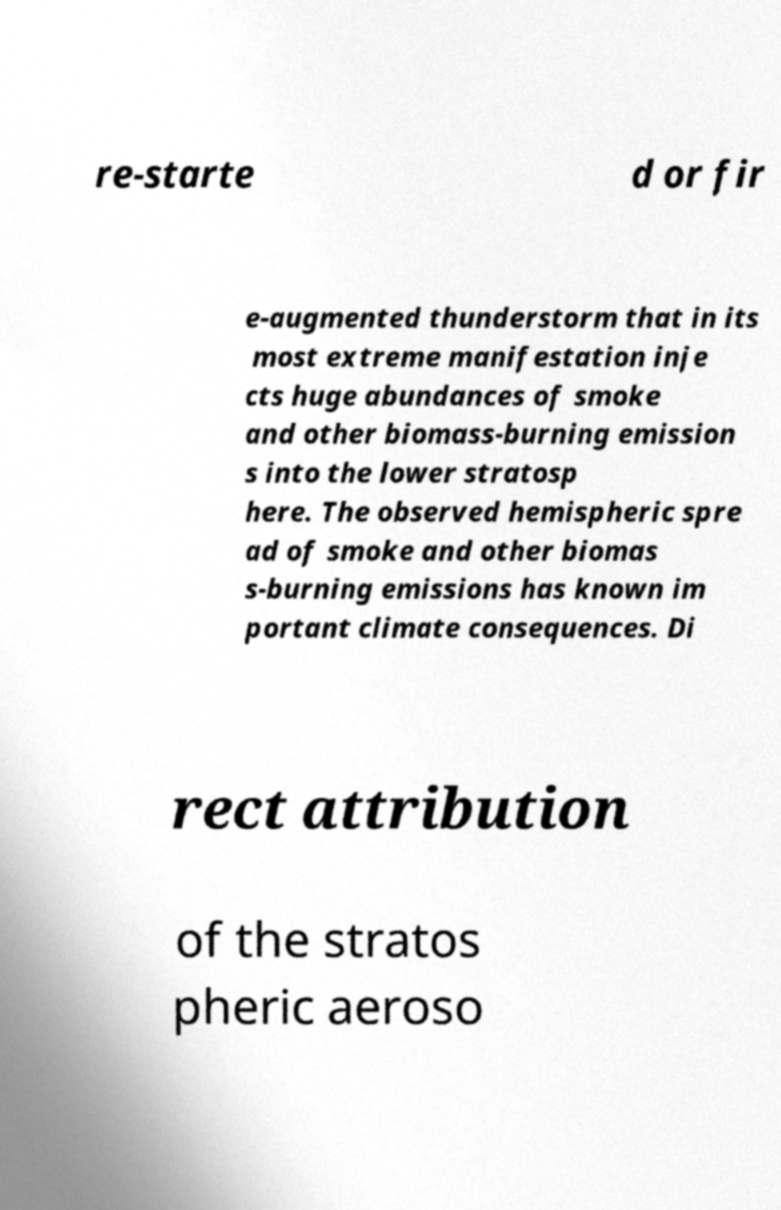Could you extract and type out the text from this image? re-starte d or fir e-augmented thunderstorm that in its most extreme manifestation inje cts huge abundances of smoke and other biomass-burning emission s into the lower stratosp here. The observed hemispheric spre ad of smoke and other biomas s-burning emissions has known im portant climate consequences. Di rect attribution of the stratos pheric aeroso 